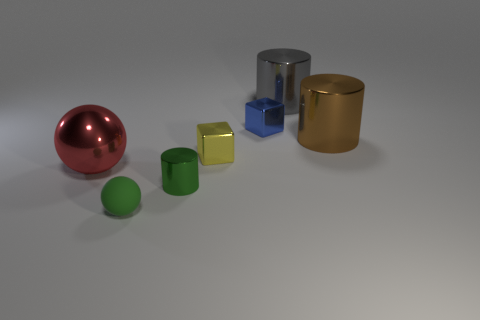Are there any other things that have the same material as the small green sphere?
Provide a short and direct response. No. Is the number of small rubber objects on the right side of the blue metallic thing the same as the number of large cyan rubber spheres?
Give a very brief answer. Yes. What number of balls have the same color as the small metallic cylinder?
Your answer should be compact. 1. The other tiny shiny thing that is the same shape as the brown metallic object is what color?
Your response must be concise. Green. Does the green rubber ball have the same size as the brown metal cylinder?
Offer a terse response. No. Are there an equal number of gray things that are to the left of the big gray cylinder and green metallic objects that are on the left side of the big brown cylinder?
Provide a short and direct response. No. Are any small red shiny blocks visible?
Give a very brief answer. No. What is the size of the green object that is the same shape as the big gray object?
Ensure brevity in your answer.  Small. There is a cylinder that is behind the blue cube; what is its size?
Your answer should be compact. Large. Are there more green rubber balls that are to the right of the small green ball than large metal objects?
Offer a very short reply. No. 